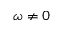<formula> <loc_0><loc_0><loc_500><loc_500>\omega \neq 0</formula> 